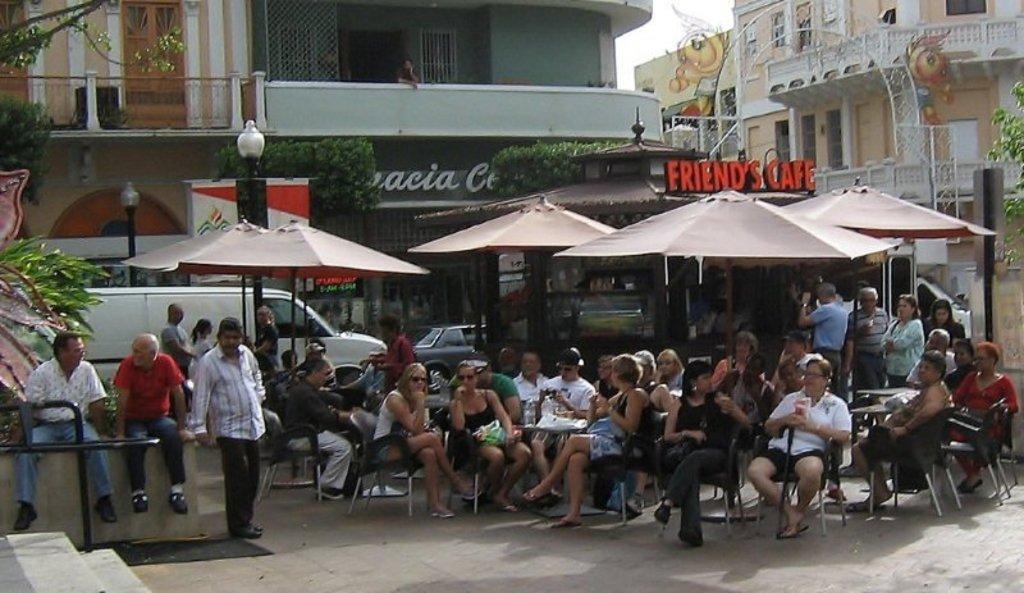In one or two sentences, can you explain what this image depicts? There is a crowd at the bottom of this image. There are some vehicles, tents and some buildings in the background. There are some trees on the left side of this image and right side of this image as well. There is one person standing at the top of this image. 